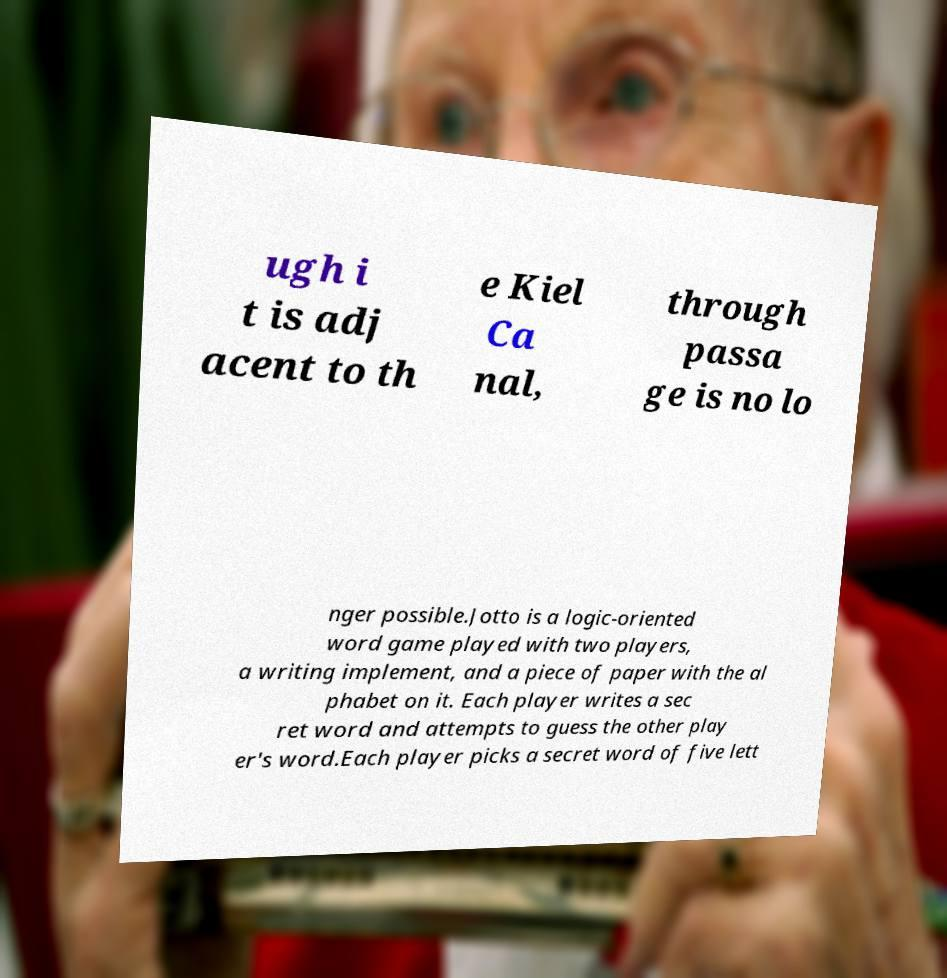What messages or text are displayed in this image? I need them in a readable, typed format. ugh i t is adj acent to th e Kiel Ca nal, through passa ge is no lo nger possible.Jotto is a logic-oriented word game played with two players, a writing implement, and a piece of paper with the al phabet on it. Each player writes a sec ret word and attempts to guess the other play er's word.Each player picks a secret word of five lett 